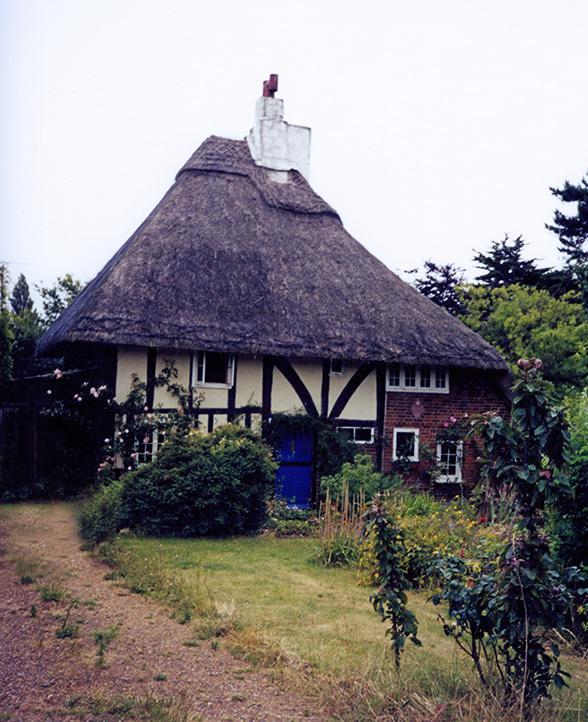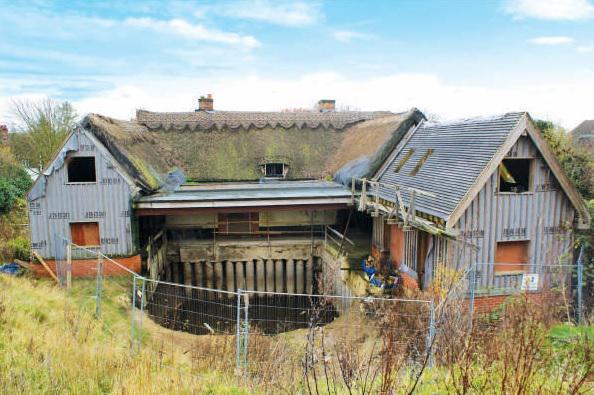The first image is the image on the left, the second image is the image on the right. Evaluate the accuracy of this statement regarding the images: "The roof in the left image is straight across the bottom and forms a simple triangle shape.". Is it true? Answer yes or no. Yes. The first image is the image on the left, the second image is the image on the right. For the images shown, is this caption "There is exactly one brick chimney." true? Answer yes or no. No. 